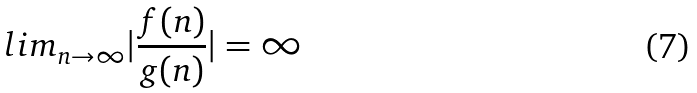Convert formula to latex. <formula><loc_0><loc_0><loc_500><loc_500>l i m _ { n \rightarrow \infty } | \frac { f ( n ) } { g ( n ) } | = \infty</formula> 